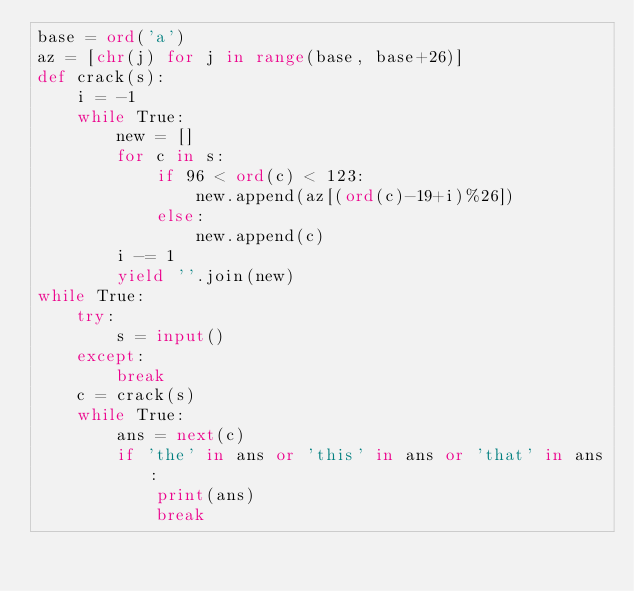<code> <loc_0><loc_0><loc_500><loc_500><_Python_>base = ord('a')
az = [chr(j) for j in range(base, base+26)]
def crack(s):
    i = -1
    while True:
        new = []
        for c in s:
            if 96 < ord(c) < 123:
                new.append(az[(ord(c)-19+i)%26])
            else:
                new.append(c)
        i -= 1
        yield ''.join(new)
while True:
    try:
        s = input()
    except:
        break
    c = crack(s)
    while True:
        ans = next(c)
        if 'the' in ans or 'this' in ans or 'that' in ans:
            print(ans)
            break</code> 